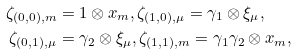Convert formula to latex. <formula><loc_0><loc_0><loc_500><loc_500>\zeta _ { ( 0 , 0 ) , m } & = 1 \otimes x _ { m } , \zeta _ { ( 1 , 0 ) , \mu } = \gamma _ { 1 } \otimes \xi _ { \mu } , \\ \zeta _ { ( 0 , 1 ) , \mu } & = \gamma _ { 2 } \otimes \xi _ { \mu } , \zeta _ { ( 1 , 1 ) , m } = \gamma _ { 1 } \gamma _ { 2 } \otimes x _ { m } ,</formula> 